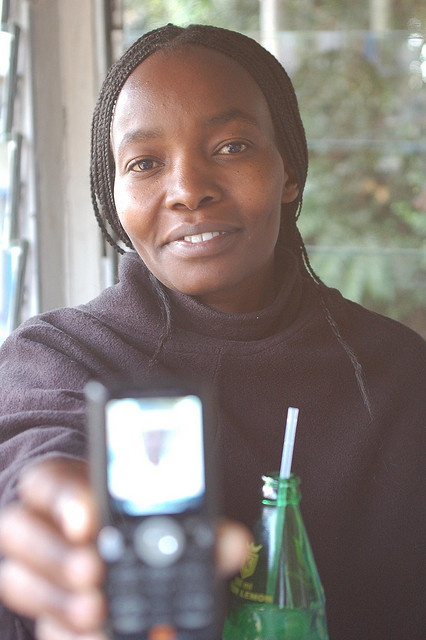Describe the objects in this image and their specific colors. I can see people in white, gray, black, and brown tones, cell phone in white, gray, and darkgray tones, and bottle in white, teal, and darkgreen tones in this image. 